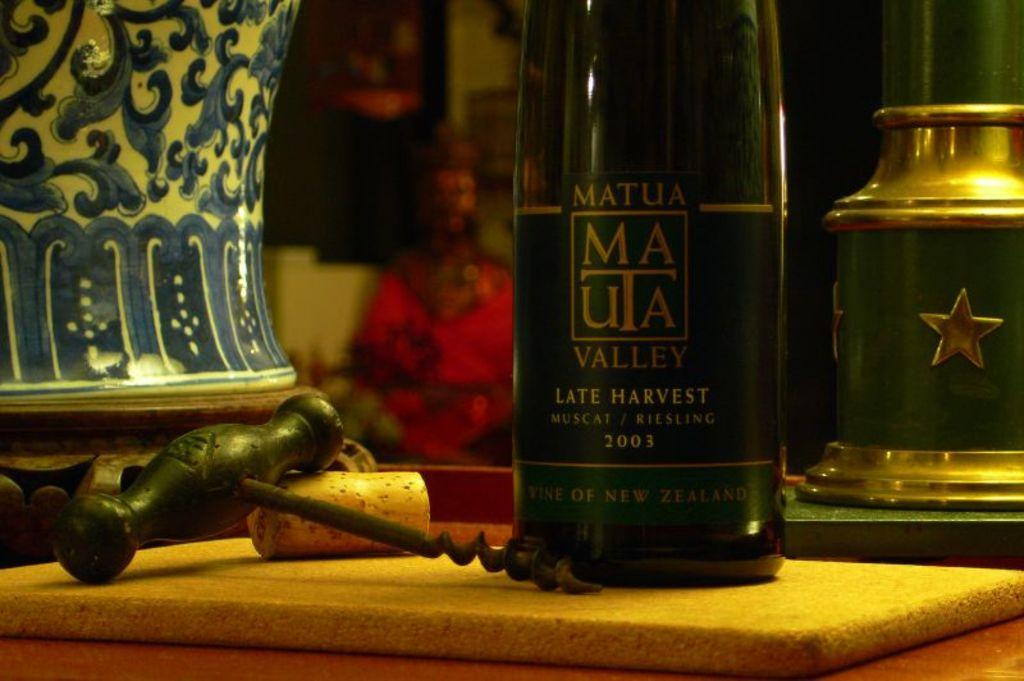<image>
Offer a succinct explanation of the picture presented. Bottle of Mauta Valley on the table with a cork screw next to it. 